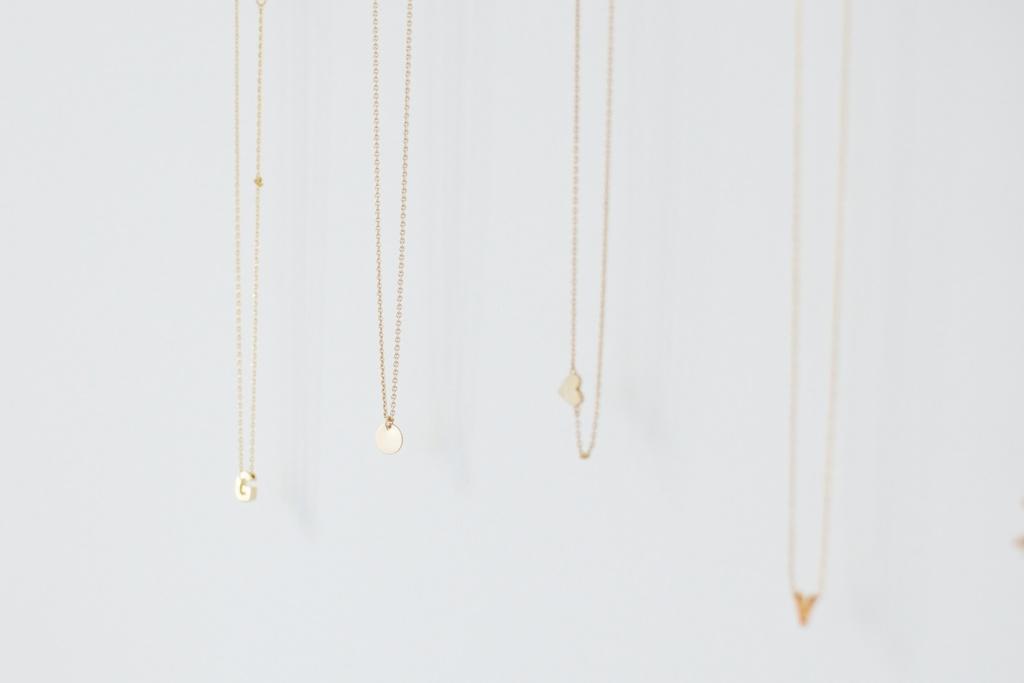Describe this image in one or two sentences. In this image, I can see four chains with pendants. There is a white background. 